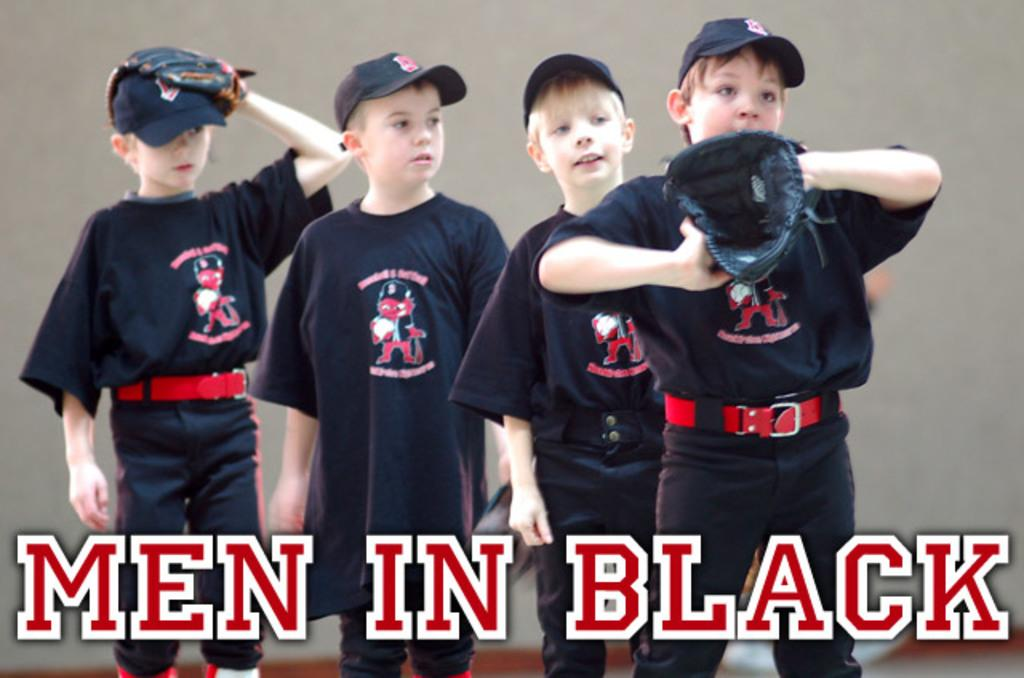<image>
Render a clear and concise summary of the photo. little boys wearing black with a title on the bottom of the picture that says 'men in black' 